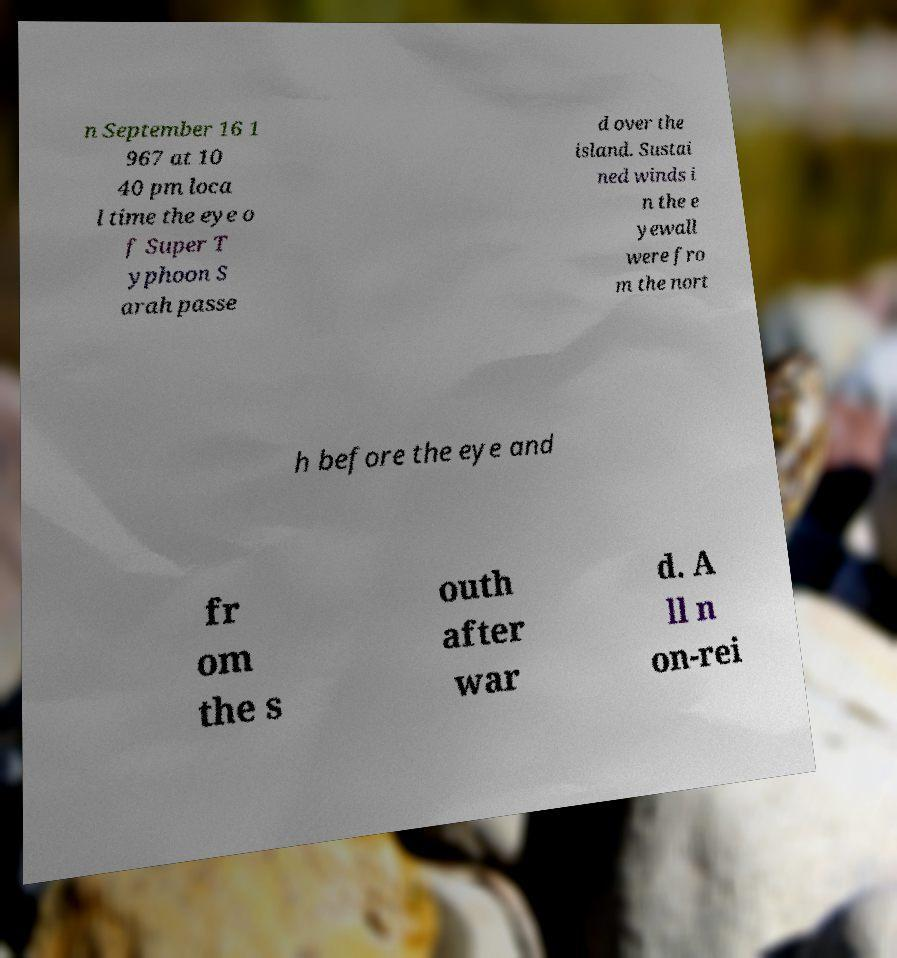Please identify and transcribe the text found in this image. n September 16 1 967 at 10 40 pm loca l time the eye o f Super T yphoon S arah passe d over the island. Sustai ned winds i n the e yewall were fro m the nort h before the eye and fr om the s outh after war d. A ll n on-rei 